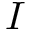Convert formula to latex. <formula><loc_0><loc_0><loc_500><loc_500>I</formula> 